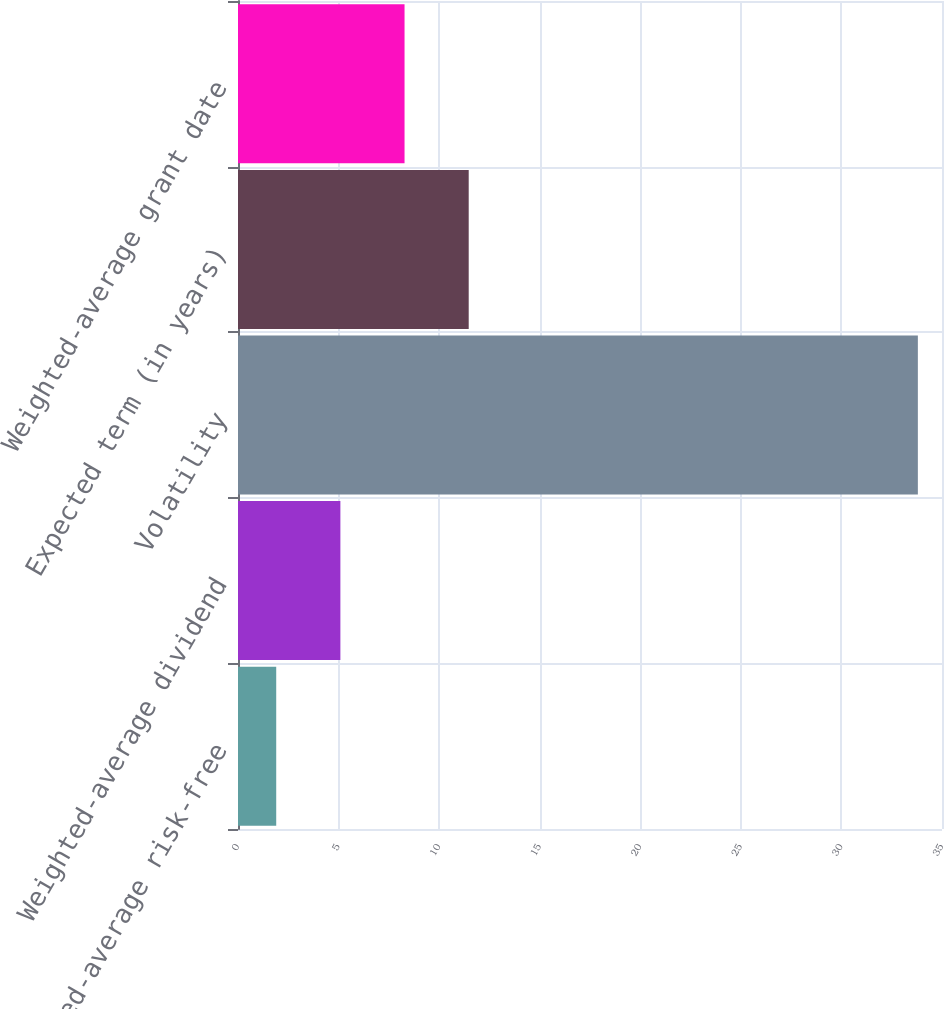Convert chart. <chart><loc_0><loc_0><loc_500><loc_500><bar_chart><fcel>Weighted-average risk-free<fcel>Weighted-average dividend<fcel>Volatility<fcel>Expected term (in years)<fcel>Weighted-average grant date<nl><fcel>1.9<fcel>5.09<fcel>33.8<fcel>11.47<fcel>8.28<nl></chart> 